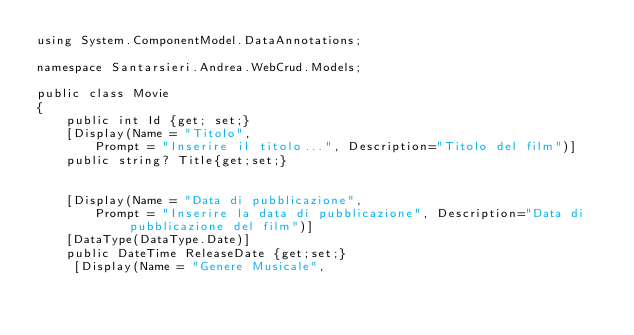<code> <loc_0><loc_0><loc_500><loc_500><_C#_>using System.ComponentModel.DataAnnotations;

namespace Santarsieri.Andrea.WebCrud.Models;

public class Movie
{
    public int Id {get; set;}
    [Display(Name = "Titolo",    
        Prompt = "Inserire il titolo...", Description="Titolo del film")]  
    public string? Title{get;set;}

    
    [Display(Name = "Data di pubblicazione",    
        Prompt = "Inserire la data di pubblicazione", Description="Data di pubblicazione del film")]  
    [DataType(DataType.Date)]
    public DateTime ReleaseDate {get;set;}
     [Display(Name = "Genere Musicale",    </code> 